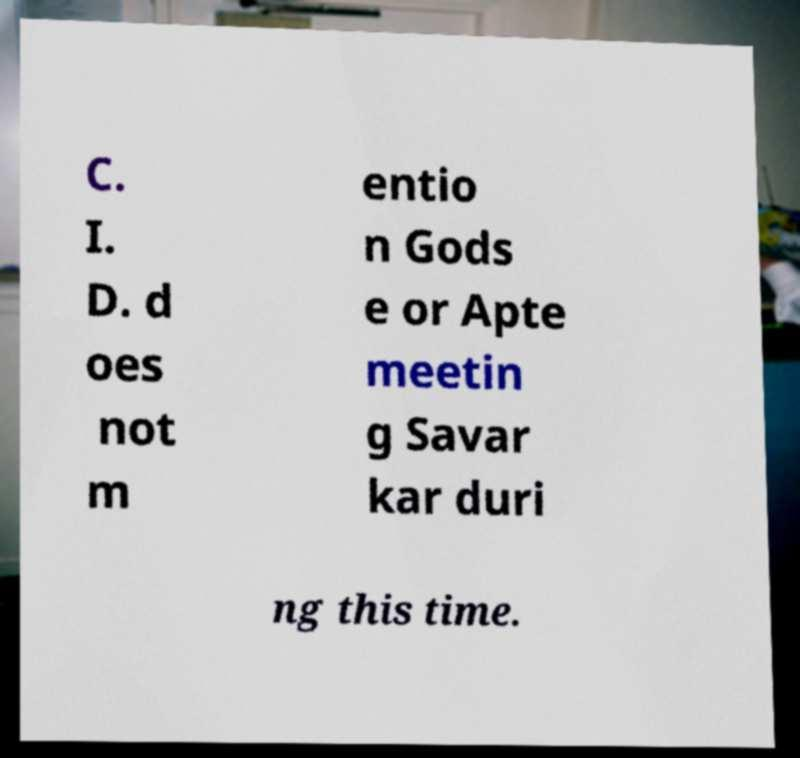For documentation purposes, I need the text within this image transcribed. Could you provide that? C. I. D. d oes not m entio n Gods e or Apte meetin g Savar kar duri ng this time. 